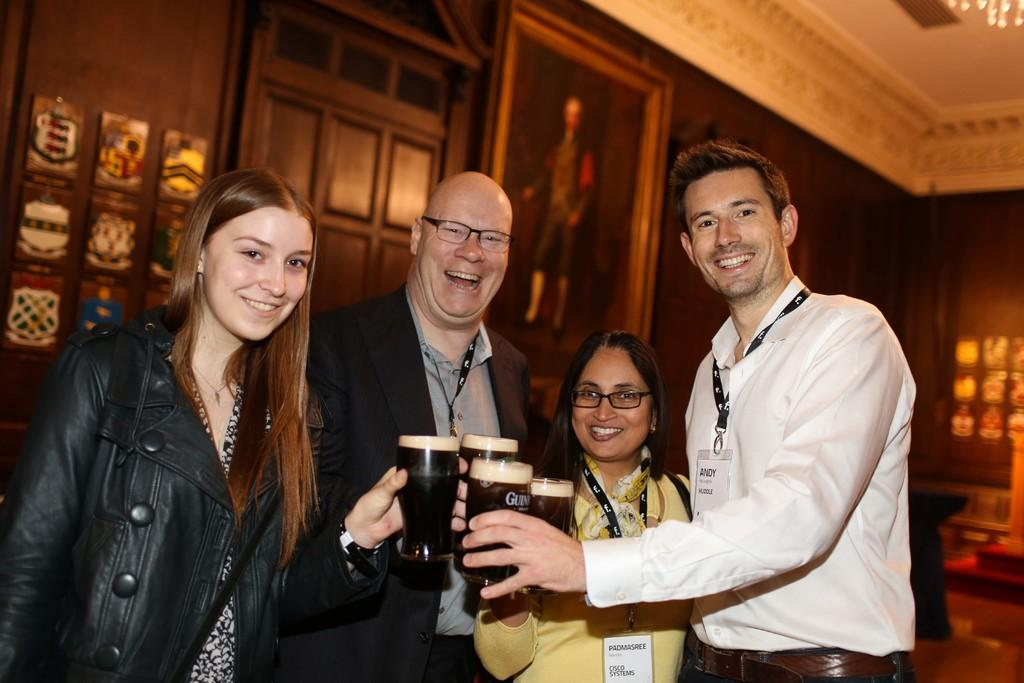How many people are in the image? There are four people in the image. Can you describe the gender of the people in the image? Two of the people are women, and two are men. What are the people doing in the image? The people are posing for the camera. What are the people holding in their hands? The people are holding glasses in their hands. Can you tell me how many basketballs are visible in the image? There are no basketballs present in the image. Is there a railway visible in the background of the image? There is no railway visible in the image. 